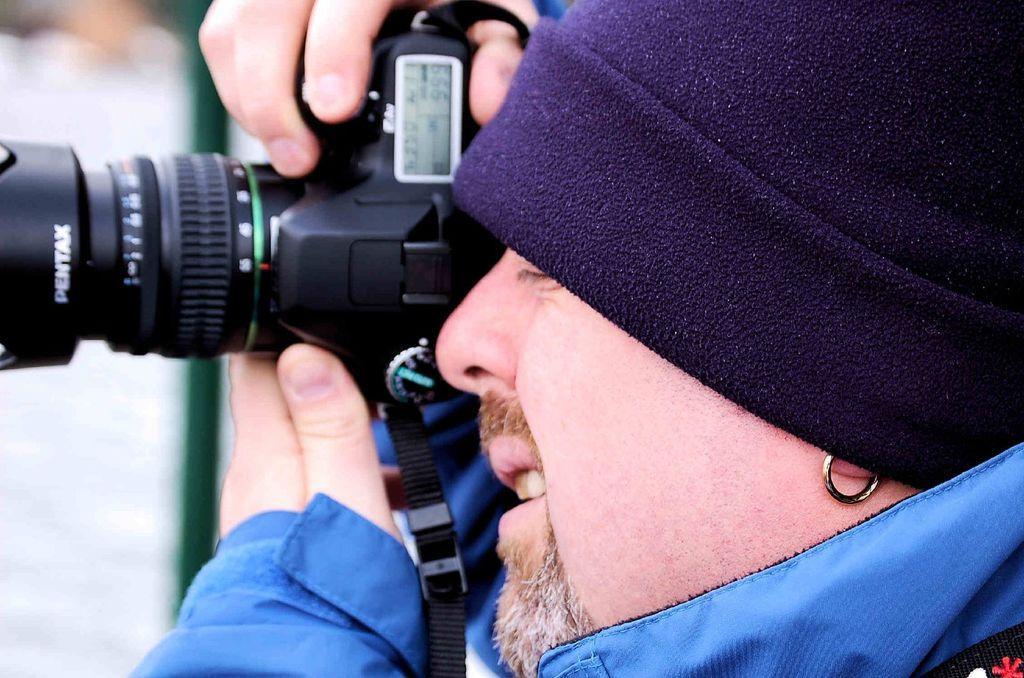Could you give a brief overview of what you see in this image? This picture shows a man taking a photograph with the camera. 